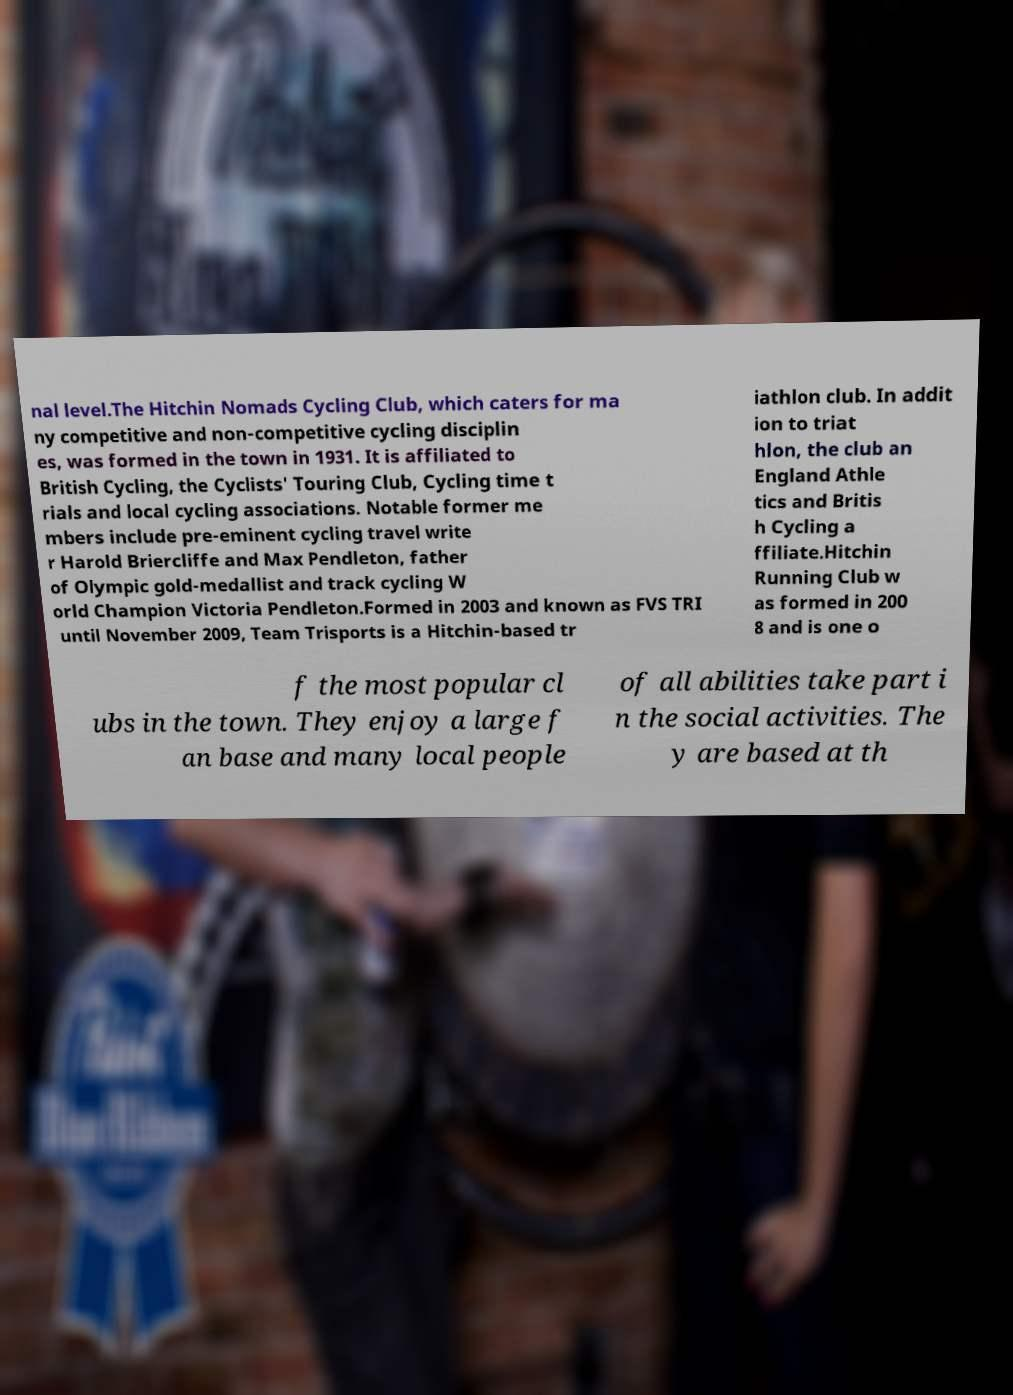For documentation purposes, I need the text within this image transcribed. Could you provide that? nal level.The Hitchin Nomads Cycling Club, which caters for ma ny competitive and non-competitive cycling disciplin es, was formed in the town in 1931. It is affiliated to British Cycling, the Cyclists' Touring Club, Cycling time t rials and local cycling associations. Notable former me mbers include pre-eminent cycling travel write r Harold Briercliffe and Max Pendleton, father of Olympic gold-medallist and track cycling W orld Champion Victoria Pendleton.Formed in 2003 and known as FVS TRI until November 2009, Team Trisports is a Hitchin-based tr iathlon club. In addit ion to triat hlon, the club an England Athle tics and Britis h Cycling a ffiliate.Hitchin Running Club w as formed in 200 8 and is one o f the most popular cl ubs in the town. They enjoy a large f an base and many local people of all abilities take part i n the social activities. The y are based at th 